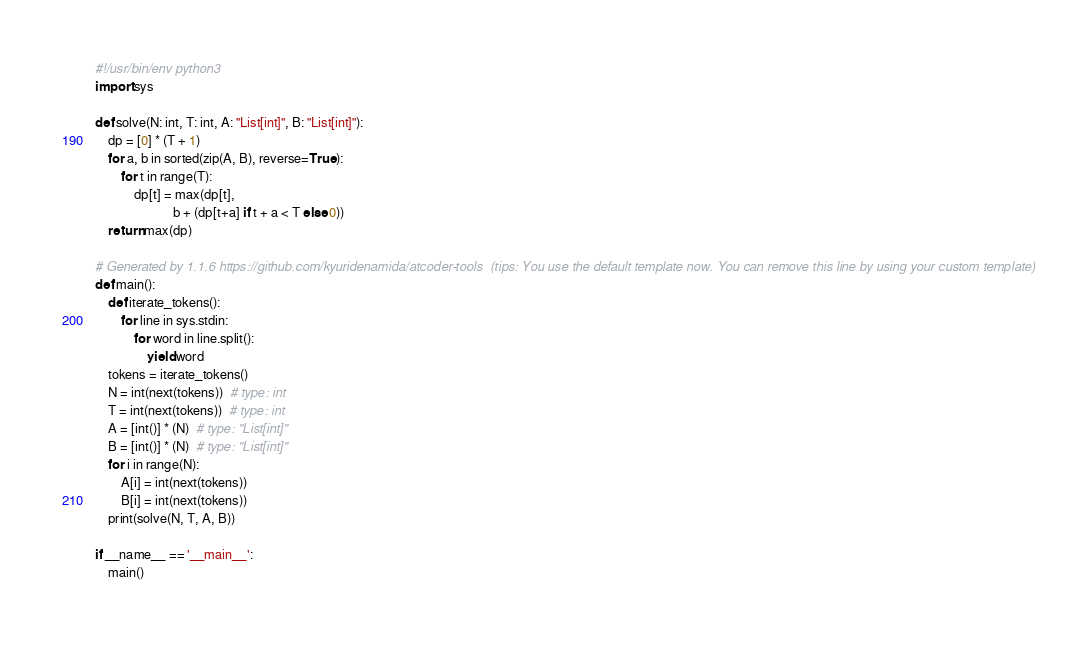Convert code to text. <code><loc_0><loc_0><loc_500><loc_500><_Python_>#!/usr/bin/env python3
import sys

def solve(N: int, T: int, A: "List[int]", B: "List[int]"):
    dp = [0] * (T + 1)
    for a, b in sorted(zip(A, B), reverse=True):
        for t in range(T):
            dp[t] = max(dp[t],
                        b + (dp[t+a] if t + a < T else 0))
    return max(dp)

# Generated by 1.1.6 https://github.com/kyuridenamida/atcoder-tools  (tips: You use the default template now. You can remove this line by using your custom template)
def main():
    def iterate_tokens():
        for line in sys.stdin:
            for word in line.split():
                yield word
    tokens = iterate_tokens()
    N = int(next(tokens))  # type: int
    T = int(next(tokens))  # type: int
    A = [int()] * (N)  # type: "List[int]"
    B = [int()] * (N)  # type: "List[int]"
    for i in range(N):
        A[i] = int(next(tokens))
        B[i] = int(next(tokens))
    print(solve(N, T, A, B))

if __name__ == '__main__':
    main()
</code> 